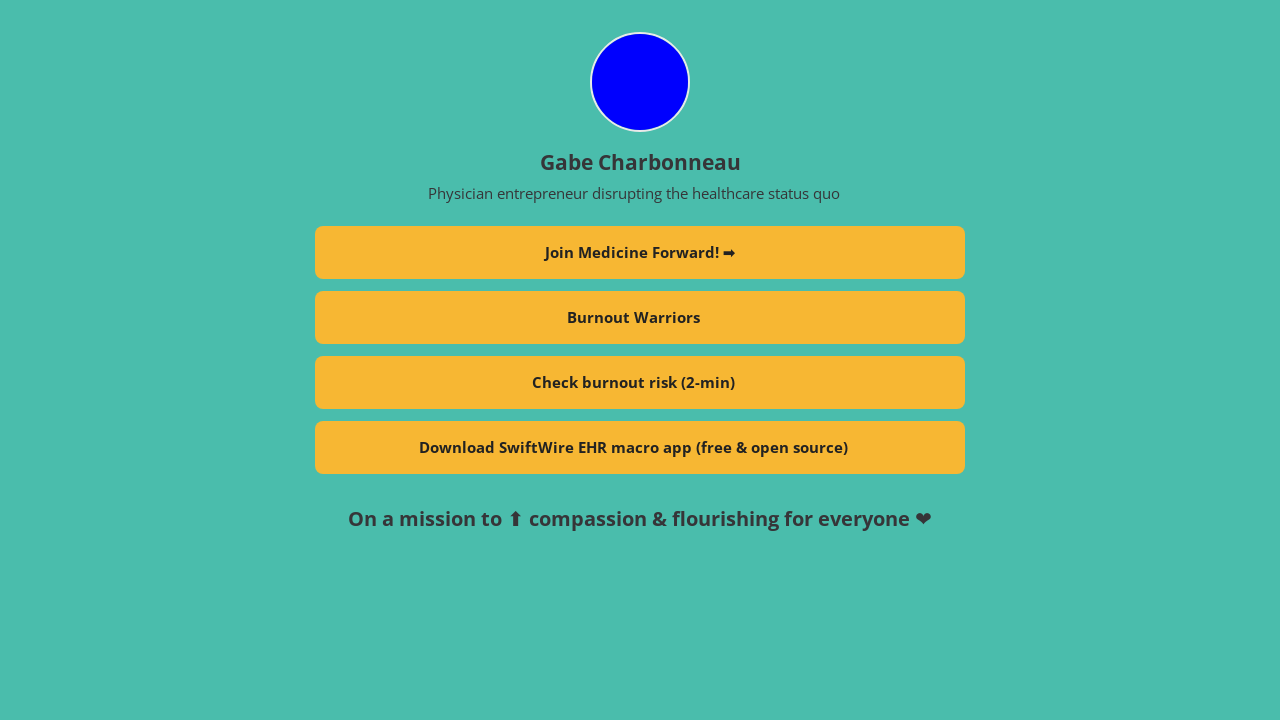Can you describe the features and benefits of the SwiftWire EHR macro app shown on the profile? The SwiftWire EHR macro app is designed to enhance the efficiency of electronic health record management. It provides customizable macros or shortcuts that automate repetitive tasks, making data entry faster and less prone to errors. This free and open-source tool supports clinicians in managing patient information more effectively, thereby saving time and focusing more on patient care. 